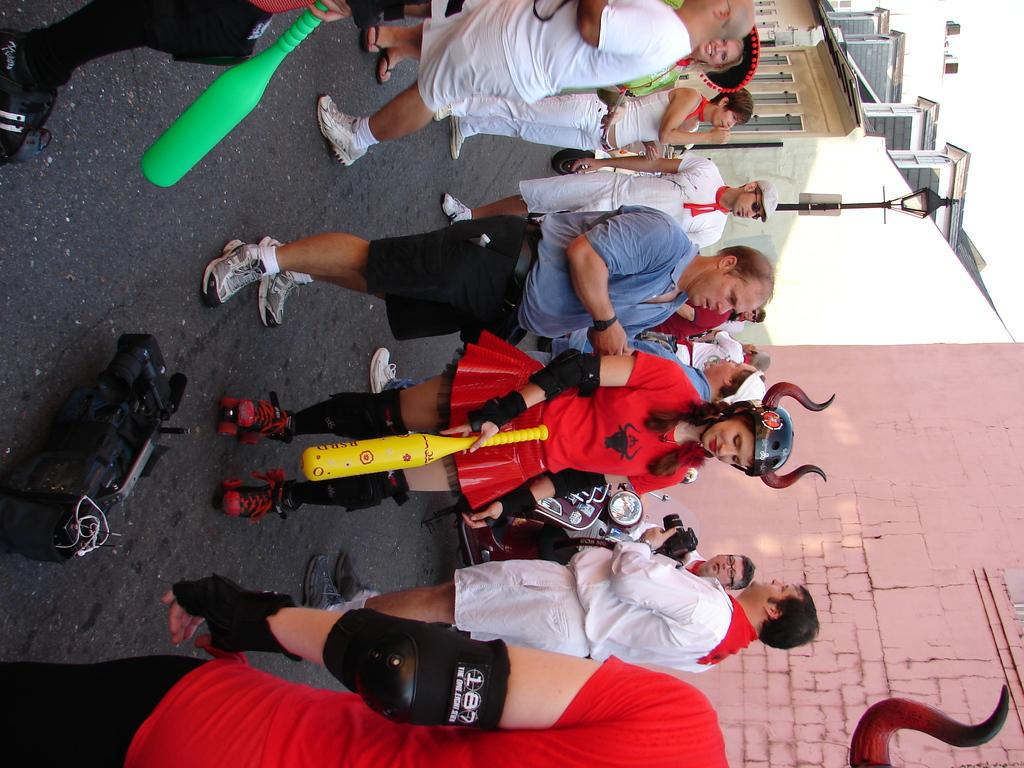How many people are in the image? There is a group of people in the image. What are two people holding in the image? Two people are holding bats in the image. What can be seen on the ground in the image? There is an object on the ground in the image. What is visible in the background of the image? There is a wall and objects visible in the background of the image. How many sheep are visible in the image? There are no sheep present in the image. What grade is the sofa in the image? There is no sofa present in the image. 